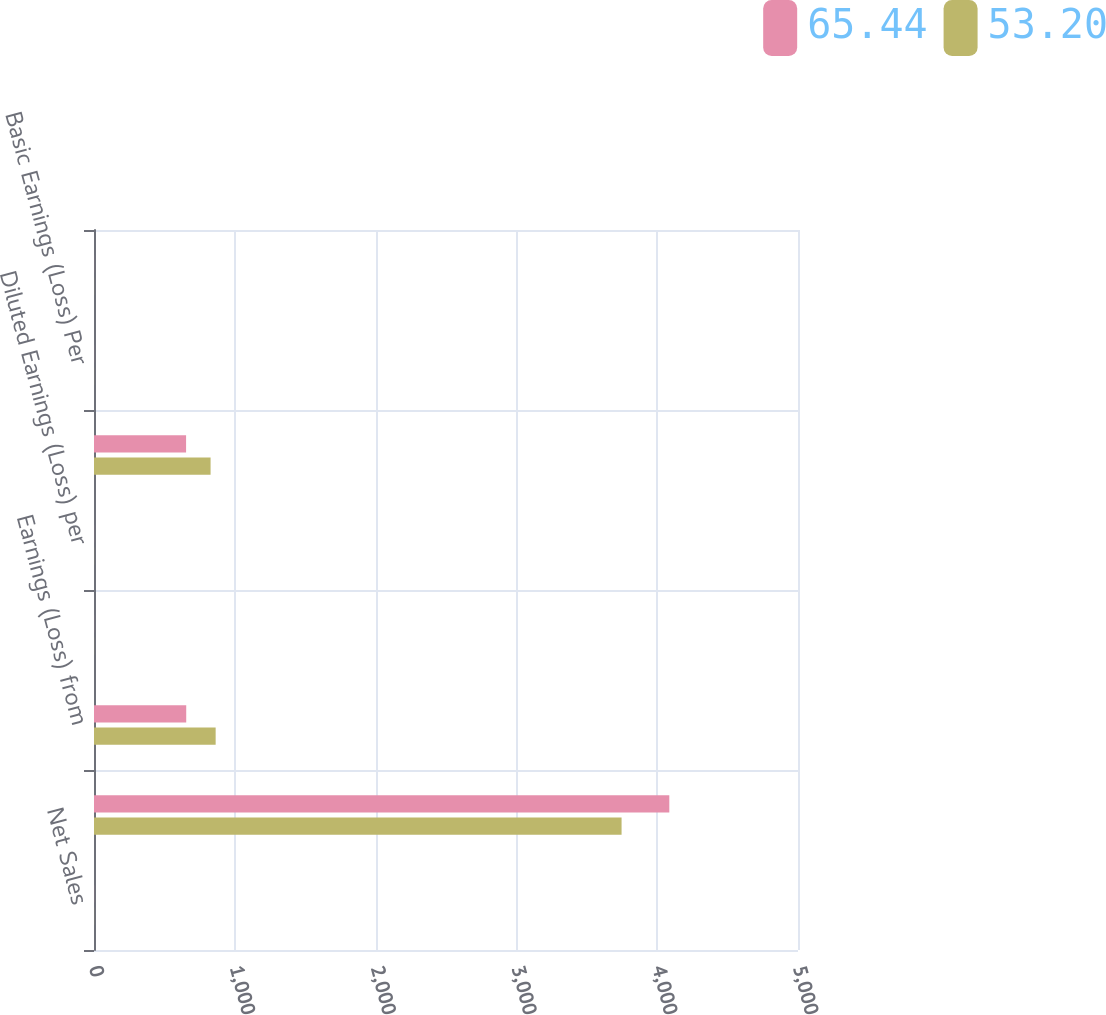Convert chart to OTSL. <chart><loc_0><loc_0><loc_500><loc_500><stacked_bar_chart><ecel><fcel>Net Sales<fcel>Gross Profit<fcel>Earnings (Loss) from<fcel>Basic Earnings (Loss) per<fcel>Diluted Earnings (Loss) per<fcel>Net Earnings (Loss)<fcel>Basic Earnings (Loss) Per<fcel>Diluted Earnings (Loss) Per<nl><fcel>65.44<fcel>0.5<fcel>4086<fcel>655<fcel>0.37<fcel>0.37<fcel>654<fcel>0.37<fcel>0.37<nl><fcel>53.2<fcel>0.5<fcel>3747<fcel>864<fcel>0.5<fcel>0.5<fcel>828<fcel>0.48<fcel>0.48<nl></chart> 